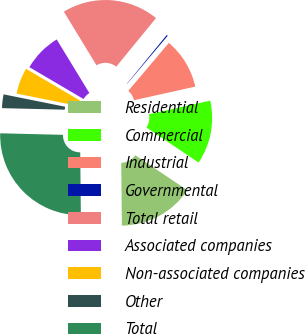Convert chart to OTSL. <chart><loc_0><loc_0><loc_500><loc_500><pie_chart><fcel>Residential<fcel>Commercial<fcel>Industrial<fcel>Governmental<fcel>Total retail<fcel>Associated companies<fcel>Non-associated companies<fcel>Other<fcel>Total<nl><fcel>15.42%<fcel>12.89%<fcel>10.36%<fcel>0.24%<fcel>19.62%<fcel>7.83%<fcel>5.3%<fcel>2.77%<fcel>25.55%<nl></chart> 